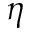<formula> <loc_0><loc_0><loc_500><loc_500>\eta</formula> 